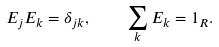Convert formula to latex. <formula><loc_0><loc_0><loc_500><loc_500>E _ { j } E _ { k } = \delta _ { j k } , \quad \sum _ { k } E _ { k } = 1 _ { R } .</formula> 